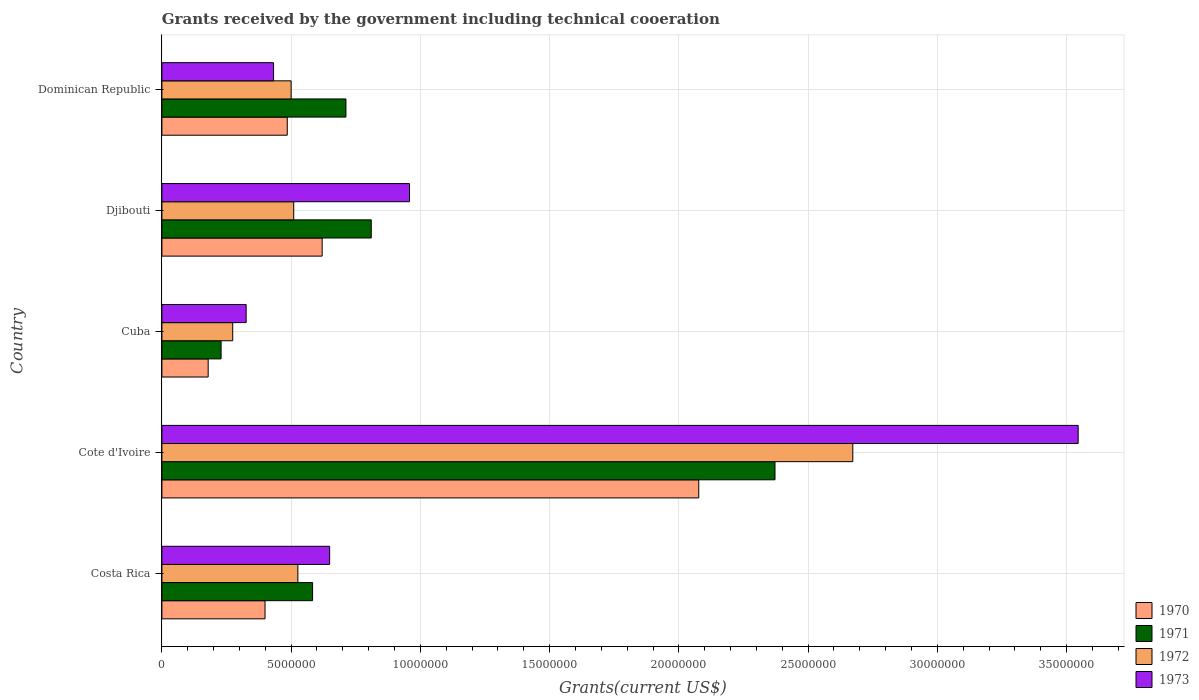How many different coloured bars are there?
Offer a very short reply. 4. Are the number of bars per tick equal to the number of legend labels?
Provide a succinct answer. Yes. Are the number of bars on each tick of the Y-axis equal?
Make the answer very short. Yes. How many bars are there on the 2nd tick from the bottom?
Make the answer very short. 4. What is the label of the 4th group of bars from the top?
Ensure brevity in your answer.  Cote d'Ivoire. In how many cases, is the number of bars for a given country not equal to the number of legend labels?
Offer a very short reply. 0. What is the total grants received by the government in 1970 in Cote d'Ivoire?
Your answer should be compact. 2.08e+07. Across all countries, what is the maximum total grants received by the government in 1971?
Your response must be concise. 2.37e+07. Across all countries, what is the minimum total grants received by the government in 1973?
Ensure brevity in your answer.  3.26e+06. In which country was the total grants received by the government in 1973 maximum?
Give a very brief answer. Cote d'Ivoire. In which country was the total grants received by the government in 1973 minimum?
Your answer should be very brief. Cuba. What is the total total grants received by the government in 1970 in the graph?
Provide a short and direct response. 3.76e+07. What is the difference between the total grants received by the government in 1973 in Costa Rica and that in Djibouti?
Offer a very short reply. -3.09e+06. What is the difference between the total grants received by the government in 1972 in Costa Rica and the total grants received by the government in 1970 in Djibouti?
Your answer should be compact. -9.40e+05. What is the average total grants received by the government in 1972 per country?
Your answer should be very brief. 8.97e+06. What is the difference between the total grants received by the government in 1971 and total grants received by the government in 1972 in Cuba?
Your answer should be compact. -4.50e+05. In how many countries, is the total grants received by the government in 1973 greater than 30000000 US$?
Offer a terse response. 1. What is the ratio of the total grants received by the government in 1973 in Djibouti to that in Dominican Republic?
Your answer should be compact. 2.22. Is the total grants received by the government in 1972 in Costa Rica less than that in Cuba?
Offer a terse response. No. Is the difference between the total grants received by the government in 1971 in Costa Rica and Dominican Republic greater than the difference between the total grants received by the government in 1972 in Costa Rica and Dominican Republic?
Keep it short and to the point. No. What is the difference between the highest and the second highest total grants received by the government in 1973?
Your response must be concise. 2.59e+07. What is the difference between the highest and the lowest total grants received by the government in 1970?
Offer a very short reply. 1.90e+07. In how many countries, is the total grants received by the government in 1971 greater than the average total grants received by the government in 1971 taken over all countries?
Your response must be concise. 1. Is the sum of the total grants received by the government in 1972 in Djibouti and Dominican Republic greater than the maximum total grants received by the government in 1970 across all countries?
Your response must be concise. No. What does the 2nd bar from the bottom in Djibouti represents?
Offer a very short reply. 1971. Is it the case that in every country, the sum of the total grants received by the government in 1973 and total grants received by the government in 1972 is greater than the total grants received by the government in 1971?
Provide a short and direct response. Yes. How many countries are there in the graph?
Provide a succinct answer. 5. Does the graph contain any zero values?
Provide a succinct answer. No. How many legend labels are there?
Make the answer very short. 4. How are the legend labels stacked?
Ensure brevity in your answer.  Vertical. What is the title of the graph?
Keep it short and to the point. Grants received by the government including technical cooeration. What is the label or title of the X-axis?
Provide a succinct answer. Grants(current US$). What is the Grants(current US$) of 1970 in Costa Rica?
Your response must be concise. 3.99e+06. What is the Grants(current US$) in 1971 in Costa Rica?
Your answer should be compact. 5.83e+06. What is the Grants(current US$) in 1972 in Costa Rica?
Ensure brevity in your answer.  5.26e+06. What is the Grants(current US$) of 1973 in Costa Rica?
Your response must be concise. 6.49e+06. What is the Grants(current US$) in 1970 in Cote d'Ivoire?
Your answer should be very brief. 2.08e+07. What is the Grants(current US$) in 1971 in Cote d'Ivoire?
Your response must be concise. 2.37e+07. What is the Grants(current US$) in 1972 in Cote d'Ivoire?
Your response must be concise. 2.67e+07. What is the Grants(current US$) in 1973 in Cote d'Ivoire?
Make the answer very short. 3.54e+07. What is the Grants(current US$) of 1970 in Cuba?
Your answer should be very brief. 1.79e+06. What is the Grants(current US$) of 1971 in Cuba?
Provide a short and direct response. 2.29e+06. What is the Grants(current US$) in 1972 in Cuba?
Keep it short and to the point. 2.74e+06. What is the Grants(current US$) in 1973 in Cuba?
Give a very brief answer. 3.26e+06. What is the Grants(current US$) of 1970 in Djibouti?
Offer a very short reply. 6.20e+06. What is the Grants(current US$) in 1971 in Djibouti?
Keep it short and to the point. 8.10e+06. What is the Grants(current US$) in 1972 in Djibouti?
Your answer should be very brief. 5.10e+06. What is the Grants(current US$) of 1973 in Djibouti?
Keep it short and to the point. 9.58e+06. What is the Grants(current US$) of 1970 in Dominican Republic?
Give a very brief answer. 4.85e+06. What is the Grants(current US$) of 1971 in Dominican Republic?
Provide a short and direct response. 7.12e+06. What is the Grants(current US$) in 1972 in Dominican Republic?
Make the answer very short. 5.00e+06. What is the Grants(current US$) of 1973 in Dominican Republic?
Your answer should be compact. 4.32e+06. Across all countries, what is the maximum Grants(current US$) in 1970?
Your response must be concise. 2.08e+07. Across all countries, what is the maximum Grants(current US$) of 1971?
Your response must be concise. 2.37e+07. Across all countries, what is the maximum Grants(current US$) in 1972?
Your answer should be very brief. 2.67e+07. Across all countries, what is the maximum Grants(current US$) in 1973?
Offer a very short reply. 3.54e+07. Across all countries, what is the minimum Grants(current US$) in 1970?
Ensure brevity in your answer.  1.79e+06. Across all countries, what is the minimum Grants(current US$) of 1971?
Your answer should be compact. 2.29e+06. Across all countries, what is the minimum Grants(current US$) of 1972?
Your answer should be very brief. 2.74e+06. Across all countries, what is the minimum Grants(current US$) of 1973?
Make the answer very short. 3.26e+06. What is the total Grants(current US$) of 1970 in the graph?
Your response must be concise. 3.76e+07. What is the total Grants(current US$) in 1971 in the graph?
Provide a succinct answer. 4.71e+07. What is the total Grants(current US$) of 1972 in the graph?
Offer a very short reply. 4.48e+07. What is the total Grants(current US$) in 1973 in the graph?
Ensure brevity in your answer.  5.91e+07. What is the difference between the Grants(current US$) in 1970 in Costa Rica and that in Cote d'Ivoire?
Give a very brief answer. -1.68e+07. What is the difference between the Grants(current US$) in 1971 in Costa Rica and that in Cote d'Ivoire?
Provide a short and direct response. -1.79e+07. What is the difference between the Grants(current US$) in 1972 in Costa Rica and that in Cote d'Ivoire?
Your response must be concise. -2.15e+07. What is the difference between the Grants(current US$) of 1973 in Costa Rica and that in Cote d'Ivoire?
Provide a succinct answer. -2.90e+07. What is the difference between the Grants(current US$) of 1970 in Costa Rica and that in Cuba?
Your response must be concise. 2.20e+06. What is the difference between the Grants(current US$) in 1971 in Costa Rica and that in Cuba?
Your answer should be very brief. 3.54e+06. What is the difference between the Grants(current US$) in 1972 in Costa Rica and that in Cuba?
Offer a terse response. 2.52e+06. What is the difference between the Grants(current US$) of 1973 in Costa Rica and that in Cuba?
Provide a short and direct response. 3.23e+06. What is the difference between the Grants(current US$) of 1970 in Costa Rica and that in Djibouti?
Offer a very short reply. -2.21e+06. What is the difference between the Grants(current US$) in 1971 in Costa Rica and that in Djibouti?
Make the answer very short. -2.27e+06. What is the difference between the Grants(current US$) in 1973 in Costa Rica and that in Djibouti?
Keep it short and to the point. -3.09e+06. What is the difference between the Grants(current US$) of 1970 in Costa Rica and that in Dominican Republic?
Give a very brief answer. -8.60e+05. What is the difference between the Grants(current US$) of 1971 in Costa Rica and that in Dominican Republic?
Ensure brevity in your answer.  -1.29e+06. What is the difference between the Grants(current US$) of 1972 in Costa Rica and that in Dominican Republic?
Give a very brief answer. 2.60e+05. What is the difference between the Grants(current US$) in 1973 in Costa Rica and that in Dominican Republic?
Give a very brief answer. 2.17e+06. What is the difference between the Grants(current US$) in 1970 in Cote d'Ivoire and that in Cuba?
Ensure brevity in your answer.  1.90e+07. What is the difference between the Grants(current US$) in 1971 in Cote d'Ivoire and that in Cuba?
Provide a short and direct response. 2.14e+07. What is the difference between the Grants(current US$) in 1972 in Cote d'Ivoire and that in Cuba?
Offer a very short reply. 2.40e+07. What is the difference between the Grants(current US$) of 1973 in Cote d'Ivoire and that in Cuba?
Ensure brevity in your answer.  3.22e+07. What is the difference between the Grants(current US$) in 1970 in Cote d'Ivoire and that in Djibouti?
Offer a very short reply. 1.46e+07. What is the difference between the Grants(current US$) in 1971 in Cote d'Ivoire and that in Djibouti?
Your response must be concise. 1.56e+07. What is the difference between the Grants(current US$) of 1972 in Cote d'Ivoire and that in Djibouti?
Keep it short and to the point. 2.16e+07. What is the difference between the Grants(current US$) of 1973 in Cote d'Ivoire and that in Djibouti?
Give a very brief answer. 2.59e+07. What is the difference between the Grants(current US$) in 1970 in Cote d'Ivoire and that in Dominican Republic?
Ensure brevity in your answer.  1.59e+07. What is the difference between the Grants(current US$) of 1971 in Cote d'Ivoire and that in Dominican Republic?
Keep it short and to the point. 1.66e+07. What is the difference between the Grants(current US$) of 1972 in Cote d'Ivoire and that in Dominican Republic?
Your response must be concise. 2.17e+07. What is the difference between the Grants(current US$) of 1973 in Cote d'Ivoire and that in Dominican Republic?
Your response must be concise. 3.11e+07. What is the difference between the Grants(current US$) in 1970 in Cuba and that in Djibouti?
Your answer should be very brief. -4.41e+06. What is the difference between the Grants(current US$) in 1971 in Cuba and that in Djibouti?
Provide a short and direct response. -5.81e+06. What is the difference between the Grants(current US$) of 1972 in Cuba and that in Djibouti?
Keep it short and to the point. -2.36e+06. What is the difference between the Grants(current US$) of 1973 in Cuba and that in Djibouti?
Your response must be concise. -6.32e+06. What is the difference between the Grants(current US$) of 1970 in Cuba and that in Dominican Republic?
Make the answer very short. -3.06e+06. What is the difference between the Grants(current US$) of 1971 in Cuba and that in Dominican Republic?
Offer a terse response. -4.83e+06. What is the difference between the Grants(current US$) in 1972 in Cuba and that in Dominican Republic?
Provide a short and direct response. -2.26e+06. What is the difference between the Grants(current US$) of 1973 in Cuba and that in Dominican Republic?
Provide a succinct answer. -1.06e+06. What is the difference between the Grants(current US$) in 1970 in Djibouti and that in Dominican Republic?
Ensure brevity in your answer.  1.35e+06. What is the difference between the Grants(current US$) in 1971 in Djibouti and that in Dominican Republic?
Give a very brief answer. 9.80e+05. What is the difference between the Grants(current US$) in 1973 in Djibouti and that in Dominican Republic?
Make the answer very short. 5.26e+06. What is the difference between the Grants(current US$) of 1970 in Costa Rica and the Grants(current US$) of 1971 in Cote d'Ivoire?
Provide a short and direct response. -1.97e+07. What is the difference between the Grants(current US$) in 1970 in Costa Rica and the Grants(current US$) in 1972 in Cote d'Ivoire?
Your answer should be compact. -2.27e+07. What is the difference between the Grants(current US$) of 1970 in Costa Rica and the Grants(current US$) of 1973 in Cote d'Ivoire?
Ensure brevity in your answer.  -3.15e+07. What is the difference between the Grants(current US$) in 1971 in Costa Rica and the Grants(current US$) in 1972 in Cote d'Ivoire?
Provide a succinct answer. -2.09e+07. What is the difference between the Grants(current US$) of 1971 in Costa Rica and the Grants(current US$) of 1973 in Cote d'Ivoire?
Your response must be concise. -2.96e+07. What is the difference between the Grants(current US$) in 1972 in Costa Rica and the Grants(current US$) in 1973 in Cote d'Ivoire?
Your response must be concise. -3.02e+07. What is the difference between the Grants(current US$) in 1970 in Costa Rica and the Grants(current US$) in 1971 in Cuba?
Your answer should be compact. 1.70e+06. What is the difference between the Grants(current US$) in 1970 in Costa Rica and the Grants(current US$) in 1972 in Cuba?
Offer a terse response. 1.25e+06. What is the difference between the Grants(current US$) of 1970 in Costa Rica and the Grants(current US$) of 1973 in Cuba?
Provide a short and direct response. 7.30e+05. What is the difference between the Grants(current US$) in 1971 in Costa Rica and the Grants(current US$) in 1972 in Cuba?
Your response must be concise. 3.09e+06. What is the difference between the Grants(current US$) in 1971 in Costa Rica and the Grants(current US$) in 1973 in Cuba?
Offer a terse response. 2.57e+06. What is the difference between the Grants(current US$) in 1972 in Costa Rica and the Grants(current US$) in 1973 in Cuba?
Keep it short and to the point. 2.00e+06. What is the difference between the Grants(current US$) of 1970 in Costa Rica and the Grants(current US$) of 1971 in Djibouti?
Keep it short and to the point. -4.11e+06. What is the difference between the Grants(current US$) in 1970 in Costa Rica and the Grants(current US$) in 1972 in Djibouti?
Give a very brief answer. -1.11e+06. What is the difference between the Grants(current US$) of 1970 in Costa Rica and the Grants(current US$) of 1973 in Djibouti?
Make the answer very short. -5.59e+06. What is the difference between the Grants(current US$) of 1971 in Costa Rica and the Grants(current US$) of 1972 in Djibouti?
Your answer should be very brief. 7.30e+05. What is the difference between the Grants(current US$) in 1971 in Costa Rica and the Grants(current US$) in 1973 in Djibouti?
Give a very brief answer. -3.75e+06. What is the difference between the Grants(current US$) in 1972 in Costa Rica and the Grants(current US$) in 1973 in Djibouti?
Make the answer very short. -4.32e+06. What is the difference between the Grants(current US$) in 1970 in Costa Rica and the Grants(current US$) in 1971 in Dominican Republic?
Your response must be concise. -3.13e+06. What is the difference between the Grants(current US$) in 1970 in Costa Rica and the Grants(current US$) in 1972 in Dominican Republic?
Provide a short and direct response. -1.01e+06. What is the difference between the Grants(current US$) of 1970 in Costa Rica and the Grants(current US$) of 1973 in Dominican Republic?
Provide a succinct answer. -3.30e+05. What is the difference between the Grants(current US$) of 1971 in Costa Rica and the Grants(current US$) of 1972 in Dominican Republic?
Your answer should be compact. 8.30e+05. What is the difference between the Grants(current US$) in 1971 in Costa Rica and the Grants(current US$) in 1973 in Dominican Republic?
Make the answer very short. 1.51e+06. What is the difference between the Grants(current US$) of 1972 in Costa Rica and the Grants(current US$) of 1973 in Dominican Republic?
Your answer should be very brief. 9.40e+05. What is the difference between the Grants(current US$) in 1970 in Cote d'Ivoire and the Grants(current US$) in 1971 in Cuba?
Offer a very short reply. 1.85e+07. What is the difference between the Grants(current US$) of 1970 in Cote d'Ivoire and the Grants(current US$) of 1972 in Cuba?
Provide a short and direct response. 1.80e+07. What is the difference between the Grants(current US$) of 1970 in Cote d'Ivoire and the Grants(current US$) of 1973 in Cuba?
Your response must be concise. 1.75e+07. What is the difference between the Grants(current US$) of 1971 in Cote d'Ivoire and the Grants(current US$) of 1972 in Cuba?
Give a very brief answer. 2.10e+07. What is the difference between the Grants(current US$) in 1971 in Cote d'Ivoire and the Grants(current US$) in 1973 in Cuba?
Give a very brief answer. 2.05e+07. What is the difference between the Grants(current US$) of 1972 in Cote d'Ivoire and the Grants(current US$) of 1973 in Cuba?
Your answer should be very brief. 2.35e+07. What is the difference between the Grants(current US$) in 1970 in Cote d'Ivoire and the Grants(current US$) in 1971 in Djibouti?
Make the answer very short. 1.27e+07. What is the difference between the Grants(current US$) of 1970 in Cote d'Ivoire and the Grants(current US$) of 1972 in Djibouti?
Offer a terse response. 1.57e+07. What is the difference between the Grants(current US$) of 1970 in Cote d'Ivoire and the Grants(current US$) of 1973 in Djibouti?
Offer a very short reply. 1.12e+07. What is the difference between the Grants(current US$) in 1971 in Cote d'Ivoire and the Grants(current US$) in 1972 in Djibouti?
Give a very brief answer. 1.86e+07. What is the difference between the Grants(current US$) of 1971 in Cote d'Ivoire and the Grants(current US$) of 1973 in Djibouti?
Offer a terse response. 1.41e+07. What is the difference between the Grants(current US$) in 1972 in Cote d'Ivoire and the Grants(current US$) in 1973 in Djibouti?
Keep it short and to the point. 1.72e+07. What is the difference between the Grants(current US$) of 1970 in Cote d'Ivoire and the Grants(current US$) of 1971 in Dominican Republic?
Offer a very short reply. 1.36e+07. What is the difference between the Grants(current US$) of 1970 in Cote d'Ivoire and the Grants(current US$) of 1972 in Dominican Republic?
Give a very brief answer. 1.58e+07. What is the difference between the Grants(current US$) in 1970 in Cote d'Ivoire and the Grants(current US$) in 1973 in Dominican Republic?
Your answer should be very brief. 1.64e+07. What is the difference between the Grants(current US$) of 1971 in Cote d'Ivoire and the Grants(current US$) of 1972 in Dominican Republic?
Provide a succinct answer. 1.87e+07. What is the difference between the Grants(current US$) of 1971 in Cote d'Ivoire and the Grants(current US$) of 1973 in Dominican Republic?
Your response must be concise. 1.94e+07. What is the difference between the Grants(current US$) in 1972 in Cote d'Ivoire and the Grants(current US$) in 1973 in Dominican Republic?
Provide a short and direct response. 2.24e+07. What is the difference between the Grants(current US$) of 1970 in Cuba and the Grants(current US$) of 1971 in Djibouti?
Your answer should be very brief. -6.31e+06. What is the difference between the Grants(current US$) in 1970 in Cuba and the Grants(current US$) in 1972 in Djibouti?
Offer a terse response. -3.31e+06. What is the difference between the Grants(current US$) of 1970 in Cuba and the Grants(current US$) of 1973 in Djibouti?
Provide a succinct answer. -7.79e+06. What is the difference between the Grants(current US$) in 1971 in Cuba and the Grants(current US$) in 1972 in Djibouti?
Keep it short and to the point. -2.81e+06. What is the difference between the Grants(current US$) of 1971 in Cuba and the Grants(current US$) of 1973 in Djibouti?
Give a very brief answer. -7.29e+06. What is the difference between the Grants(current US$) in 1972 in Cuba and the Grants(current US$) in 1973 in Djibouti?
Your response must be concise. -6.84e+06. What is the difference between the Grants(current US$) of 1970 in Cuba and the Grants(current US$) of 1971 in Dominican Republic?
Ensure brevity in your answer.  -5.33e+06. What is the difference between the Grants(current US$) in 1970 in Cuba and the Grants(current US$) in 1972 in Dominican Republic?
Provide a short and direct response. -3.21e+06. What is the difference between the Grants(current US$) of 1970 in Cuba and the Grants(current US$) of 1973 in Dominican Republic?
Offer a very short reply. -2.53e+06. What is the difference between the Grants(current US$) of 1971 in Cuba and the Grants(current US$) of 1972 in Dominican Republic?
Give a very brief answer. -2.71e+06. What is the difference between the Grants(current US$) in 1971 in Cuba and the Grants(current US$) in 1973 in Dominican Republic?
Your answer should be very brief. -2.03e+06. What is the difference between the Grants(current US$) of 1972 in Cuba and the Grants(current US$) of 1973 in Dominican Republic?
Keep it short and to the point. -1.58e+06. What is the difference between the Grants(current US$) in 1970 in Djibouti and the Grants(current US$) in 1971 in Dominican Republic?
Offer a very short reply. -9.20e+05. What is the difference between the Grants(current US$) of 1970 in Djibouti and the Grants(current US$) of 1972 in Dominican Republic?
Offer a very short reply. 1.20e+06. What is the difference between the Grants(current US$) in 1970 in Djibouti and the Grants(current US$) in 1973 in Dominican Republic?
Your response must be concise. 1.88e+06. What is the difference between the Grants(current US$) of 1971 in Djibouti and the Grants(current US$) of 1972 in Dominican Republic?
Make the answer very short. 3.10e+06. What is the difference between the Grants(current US$) in 1971 in Djibouti and the Grants(current US$) in 1973 in Dominican Republic?
Your answer should be very brief. 3.78e+06. What is the difference between the Grants(current US$) in 1972 in Djibouti and the Grants(current US$) in 1973 in Dominican Republic?
Offer a very short reply. 7.80e+05. What is the average Grants(current US$) in 1970 per country?
Offer a terse response. 7.52e+06. What is the average Grants(current US$) in 1971 per country?
Provide a succinct answer. 9.41e+06. What is the average Grants(current US$) of 1972 per country?
Your answer should be compact. 8.97e+06. What is the average Grants(current US$) of 1973 per country?
Provide a short and direct response. 1.18e+07. What is the difference between the Grants(current US$) of 1970 and Grants(current US$) of 1971 in Costa Rica?
Provide a succinct answer. -1.84e+06. What is the difference between the Grants(current US$) of 1970 and Grants(current US$) of 1972 in Costa Rica?
Make the answer very short. -1.27e+06. What is the difference between the Grants(current US$) in 1970 and Grants(current US$) in 1973 in Costa Rica?
Your answer should be compact. -2.50e+06. What is the difference between the Grants(current US$) of 1971 and Grants(current US$) of 1972 in Costa Rica?
Make the answer very short. 5.70e+05. What is the difference between the Grants(current US$) of 1971 and Grants(current US$) of 1973 in Costa Rica?
Your response must be concise. -6.60e+05. What is the difference between the Grants(current US$) in 1972 and Grants(current US$) in 1973 in Costa Rica?
Your answer should be compact. -1.23e+06. What is the difference between the Grants(current US$) in 1970 and Grants(current US$) in 1971 in Cote d'Ivoire?
Your response must be concise. -2.95e+06. What is the difference between the Grants(current US$) in 1970 and Grants(current US$) in 1972 in Cote d'Ivoire?
Your answer should be very brief. -5.96e+06. What is the difference between the Grants(current US$) of 1970 and Grants(current US$) of 1973 in Cote d'Ivoire?
Offer a very short reply. -1.47e+07. What is the difference between the Grants(current US$) of 1971 and Grants(current US$) of 1972 in Cote d'Ivoire?
Make the answer very short. -3.01e+06. What is the difference between the Grants(current US$) of 1971 and Grants(current US$) of 1973 in Cote d'Ivoire?
Your answer should be very brief. -1.17e+07. What is the difference between the Grants(current US$) in 1972 and Grants(current US$) in 1973 in Cote d'Ivoire?
Provide a short and direct response. -8.72e+06. What is the difference between the Grants(current US$) of 1970 and Grants(current US$) of 1971 in Cuba?
Provide a short and direct response. -5.00e+05. What is the difference between the Grants(current US$) in 1970 and Grants(current US$) in 1972 in Cuba?
Make the answer very short. -9.50e+05. What is the difference between the Grants(current US$) in 1970 and Grants(current US$) in 1973 in Cuba?
Offer a terse response. -1.47e+06. What is the difference between the Grants(current US$) of 1971 and Grants(current US$) of 1972 in Cuba?
Give a very brief answer. -4.50e+05. What is the difference between the Grants(current US$) of 1971 and Grants(current US$) of 1973 in Cuba?
Your response must be concise. -9.70e+05. What is the difference between the Grants(current US$) of 1972 and Grants(current US$) of 1973 in Cuba?
Give a very brief answer. -5.20e+05. What is the difference between the Grants(current US$) in 1970 and Grants(current US$) in 1971 in Djibouti?
Your response must be concise. -1.90e+06. What is the difference between the Grants(current US$) in 1970 and Grants(current US$) in 1972 in Djibouti?
Your answer should be very brief. 1.10e+06. What is the difference between the Grants(current US$) in 1970 and Grants(current US$) in 1973 in Djibouti?
Offer a very short reply. -3.38e+06. What is the difference between the Grants(current US$) in 1971 and Grants(current US$) in 1973 in Djibouti?
Ensure brevity in your answer.  -1.48e+06. What is the difference between the Grants(current US$) of 1972 and Grants(current US$) of 1973 in Djibouti?
Make the answer very short. -4.48e+06. What is the difference between the Grants(current US$) in 1970 and Grants(current US$) in 1971 in Dominican Republic?
Your response must be concise. -2.27e+06. What is the difference between the Grants(current US$) in 1970 and Grants(current US$) in 1972 in Dominican Republic?
Keep it short and to the point. -1.50e+05. What is the difference between the Grants(current US$) of 1970 and Grants(current US$) of 1973 in Dominican Republic?
Your answer should be very brief. 5.30e+05. What is the difference between the Grants(current US$) in 1971 and Grants(current US$) in 1972 in Dominican Republic?
Make the answer very short. 2.12e+06. What is the difference between the Grants(current US$) in 1971 and Grants(current US$) in 1973 in Dominican Republic?
Your response must be concise. 2.80e+06. What is the difference between the Grants(current US$) in 1972 and Grants(current US$) in 1973 in Dominican Republic?
Offer a terse response. 6.80e+05. What is the ratio of the Grants(current US$) in 1970 in Costa Rica to that in Cote d'Ivoire?
Provide a short and direct response. 0.19. What is the ratio of the Grants(current US$) of 1971 in Costa Rica to that in Cote d'Ivoire?
Offer a very short reply. 0.25. What is the ratio of the Grants(current US$) in 1972 in Costa Rica to that in Cote d'Ivoire?
Your response must be concise. 0.2. What is the ratio of the Grants(current US$) in 1973 in Costa Rica to that in Cote d'Ivoire?
Your response must be concise. 0.18. What is the ratio of the Grants(current US$) in 1970 in Costa Rica to that in Cuba?
Ensure brevity in your answer.  2.23. What is the ratio of the Grants(current US$) in 1971 in Costa Rica to that in Cuba?
Keep it short and to the point. 2.55. What is the ratio of the Grants(current US$) in 1972 in Costa Rica to that in Cuba?
Offer a very short reply. 1.92. What is the ratio of the Grants(current US$) in 1973 in Costa Rica to that in Cuba?
Your answer should be very brief. 1.99. What is the ratio of the Grants(current US$) of 1970 in Costa Rica to that in Djibouti?
Keep it short and to the point. 0.64. What is the ratio of the Grants(current US$) in 1971 in Costa Rica to that in Djibouti?
Ensure brevity in your answer.  0.72. What is the ratio of the Grants(current US$) of 1972 in Costa Rica to that in Djibouti?
Give a very brief answer. 1.03. What is the ratio of the Grants(current US$) in 1973 in Costa Rica to that in Djibouti?
Make the answer very short. 0.68. What is the ratio of the Grants(current US$) of 1970 in Costa Rica to that in Dominican Republic?
Make the answer very short. 0.82. What is the ratio of the Grants(current US$) of 1971 in Costa Rica to that in Dominican Republic?
Offer a very short reply. 0.82. What is the ratio of the Grants(current US$) of 1972 in Costa Rica to that in Dominican Republic?
Provide a succinct answer. 1.05. What is the ratio of the Grants(current US$) of 1973 in Costa Rica to that in Dominican Republic?
Provide a succinct answer. 1.5. What is the ratio of the Grants(current US$) of 1970 in Cote d'Ivoire to that in Cuba?
Keep it short and to the point. 11.6. What is the ratio of the Grants(current US$) of 1971 in Cote d'Ivoire to that in Cuba?
Provide a succinct answer. 10.36. What is the ratio of the Grants(current US$) of 1972 in Cote d'Ivoire to that in Cuba?
Your response must be concise. 9.76. What is the ratio of the Grants(current US$) of 1973 in Cote d'Ivoire to that in Cuba?
Your answer should be very brief. 10.87. What is the ratio of the Grants(current US$) of 1970 in Cote d'Ivoire to that in Djibouti?
Give a very brief answer. 3.35. What is the ratio of the Grants(current US$) of 1971 in Cote d'Ivoire to that in Djibouti?
Give a very brief answer. 2.93. What is the ratio of the Grants(current US$) of 1972 in Cote d'Ivoire to that in Djibouti?
Ensure brevity in your answer.  5.24. What is the ratio of the Grants(current US$) in 1973 in Cote d'Ivoire to that in Djibouti?
Provide a succinct answer. 3.7. What is the ratio of the Grants(current US$) in 1970 in Cote d'Ivoire to that in Dominican Republic?
Provide a succinct answer. 4.28. What is the ratio of the Grants(current US$) of 1971 in Cote d'Ivoire to that in Dominican Republic?
Your answer should be very brief. 3.33. What is the ratio of the Grants(current US$) of 1972 in Cote d'Ivoire to that in Dominican Republic?
Your answer should be very brief. 5.35. What is the ratio of the Grants(current US$) of 1973 in Cote d'Ivoire to that in Dominican Republic?
Provide a succinct answer. 8.21. What is the ratio of the Grants(current US$) of 1970 in Cuba to that in Djibouti?
Keep it short and to the point. 0.29. What is the ratio of the Grants(current US$) in 1971 in Cuba to that in Djibouti?
Your answer should be compact. 0.28. What is the ratio of the Grants(current US$) of 1972 in Cuba to that in Djibouti?
Keep it short and to the point. 0.54. What is the ratio of the Grants(current US$) in 1973 in Cuba to that in Djibouti?
Offer a very short reply. 0.34. What is the ratio of the Grants(current US$) in 1970 in Cuba to that in Dominican Republic?
Your answer should be very brief. 0.37. What is the ratio of the Grants(current US$) of 1971 in Cuba to that in Dominican Republic?
Your answer should be very brief. 0.32. What is the ratio of the Grants(current US$) in 1972 in Cuba to that in Dominican Republic?
Ensure brevity in your answer.  0.55. What is the ratio of the Grants(current US$) of 1973 in Cuba to that in Dominican Republic?
Your answer should be compact. 0.75. What is the ratio of the Grants(current US$) of 1970 in Djibouti to that in Dominican Republic?
Offer a terse response. 1.28. What is the ratio of the Grants(current US$) in 1971 in Djibouti to that in Dominican Republic?
Provide a short and direct response. 1.14. What is the ratio of the Grants(current US$) in 1972 in Djibouti to that in Dominican Republic?
Offer a terse response. 1.02. What is the ratio of the Grants(current US$) in 1973 in Djibouti to that in Dominican Republic?
Your answer should be very brief. 2.22. What is the difference between the highest and the second highest Grants(current US$) of 1970?
Your answer should be compact. 1.46e+07. What is the difference between the highest and the second highest Grants(current US$) in 1971?
Your answer should be compact. 1.56e+07. What is the difference between the highest and the second highest Grants(current US$) in 1972?
Your answer should be very brief. 2.15e+07. What is the difference between the highest and the second highest Grants(current US$) in 1973?
Your response must be concise. 2.59e+07. What is the difference between the highest and the lowest Grants(current US$) of 1970?
Your answer should be very brief. 1.90e+07. What is the difference between the highest and the lowest Grants(current US$) in 1971?
Ensure brevity in your answer.  2.14e+07. What is the difference between the highest and the lowest Grants(current US$) of 1972?
Give a very brief answer. 2.40e+07. What is the difference between the highest and the lowest Grants(current US$) in 1973?
Keep it short and to the point. 3.22e+07. 